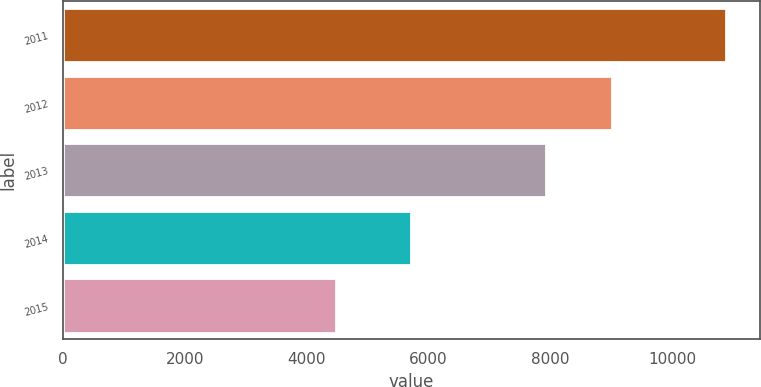Convert chart to OTSL. <chart><loc_0><loc_0><loc_500><loc_500><bar_chart><fcel>2011<fcel>2012<fcel>2013<fcel>2014<fcel>2015<nl><fcel>10886<fcel>9008<fcel>7934<fcel>5715<fcel>4479<nl></chart> 